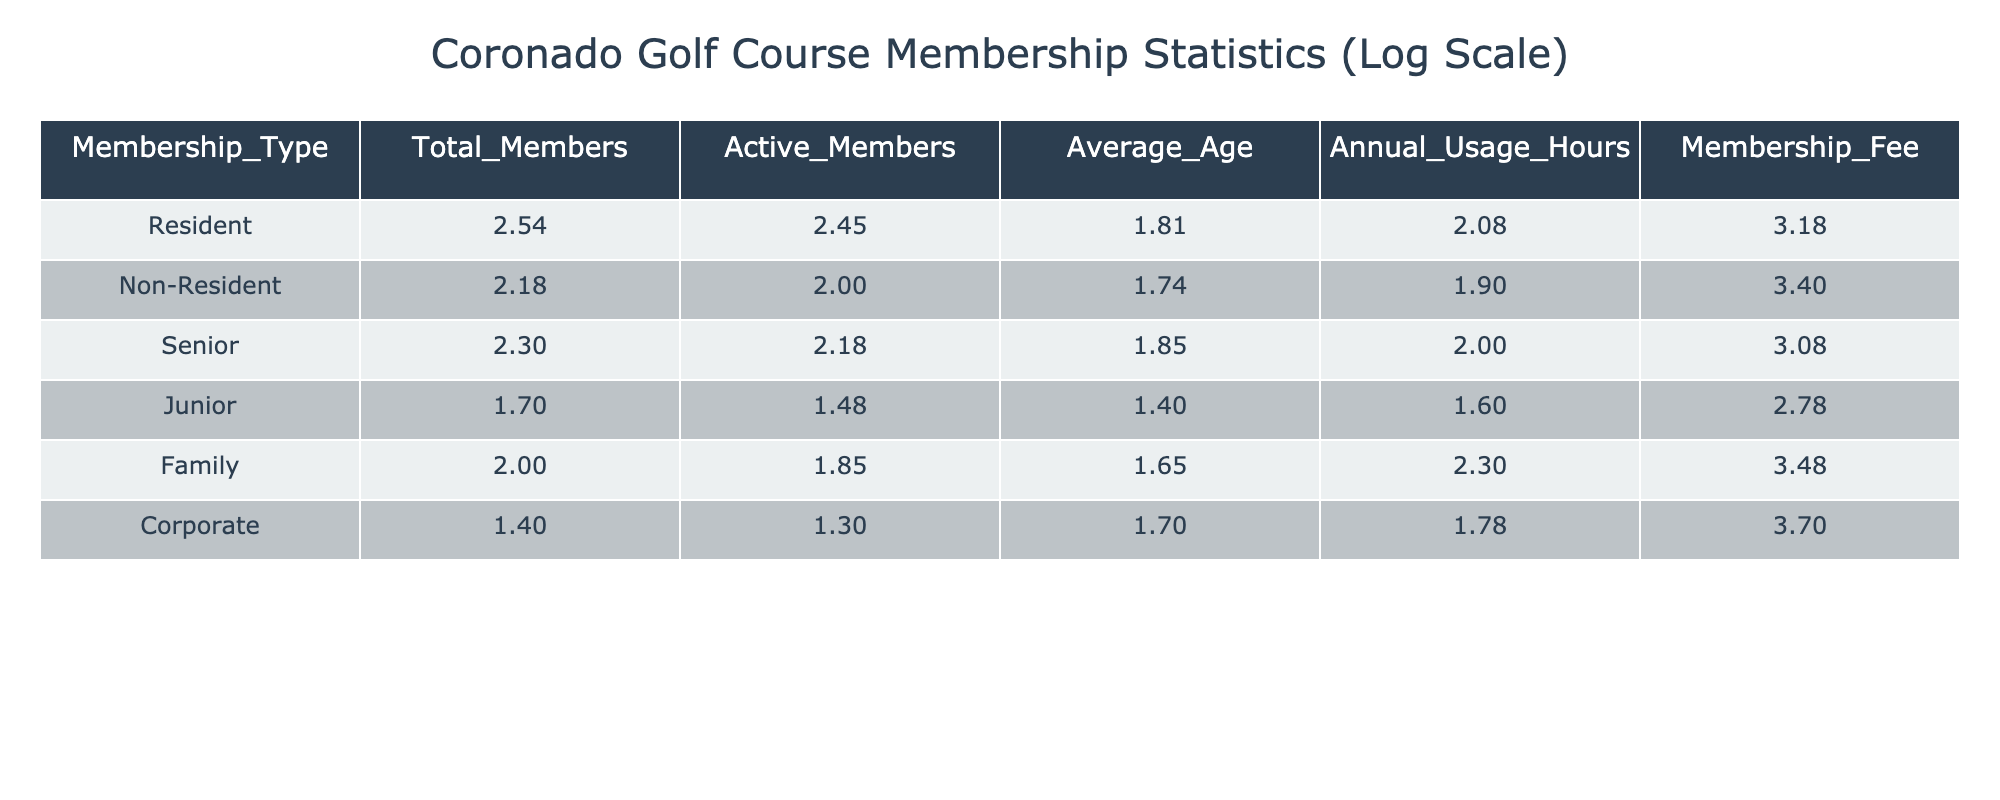What's the average age of Resident members? The average age for Resident members is given directly in the table under the "Average_Age" column, which shows a value of 65.
Answer: 65 How many total members are there in the Family membership type? The table lists the total members of the Family membership type in the "Total_Members" column, which is 100.
Answer: 100 Is the Annual Usage Hours higher for Non-Resident members than for Junior members? The Annual Usage Hours for Non-Resident members is 80 and for Junior members is 40. Since 80 is greater than 40, the statement is true.
Answer: Yes What is the total number of Active Members across all types? To find the total number of Active Members, sum the Active_Members across all membership types: 280 + 100 + 150 + 30 + 70 + 20 = 650.
Answer: 650 Which membership type has the highest Membership Fee? The Membership Fee for each type is given in the "Membership_Fee" column. The Corporate membership type has the highest fee at 5000.
Answer: Corporate What is the average Annual Usage Hours for Senior and Family members combined? First, take the Annual Usage Hours for Senior (100) and Family (200) members. Combine them: 100 + 200 = 300. Divide by the number of types (2): 300 / 2 = 150.
Answer: 150 Are there more Active Members who are Seniors than there are Junior Active Members? The Active Members for Seniors is 150 and for Juniors is 30. Since 150 is greater than 30, the statement is true.
Answer: Yes What is the difference in average age between Resident and Non-Resident members? The average age for Residents is 65, and for Non-Residents, it is 55. Calculate the difference: 65 - 55 = 10.
Answer: 10 If all members paid their Membership Fee, what would the total revenue from Corporate members be? The Corporate membership type has 25 total members and a Membership Fee of 5000. Multiply the numbers: 25 * 5000 = 125000.
Answer: 125000 